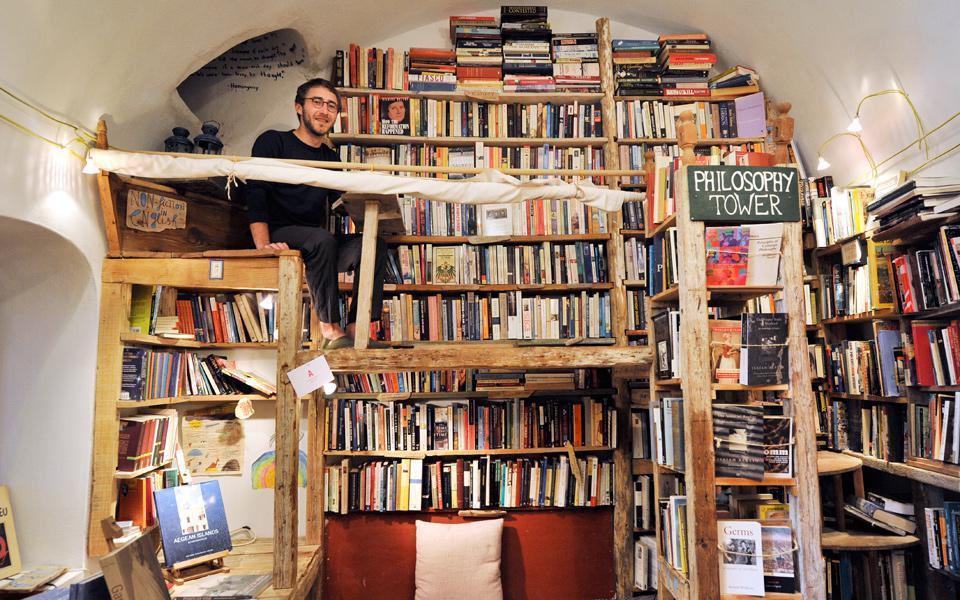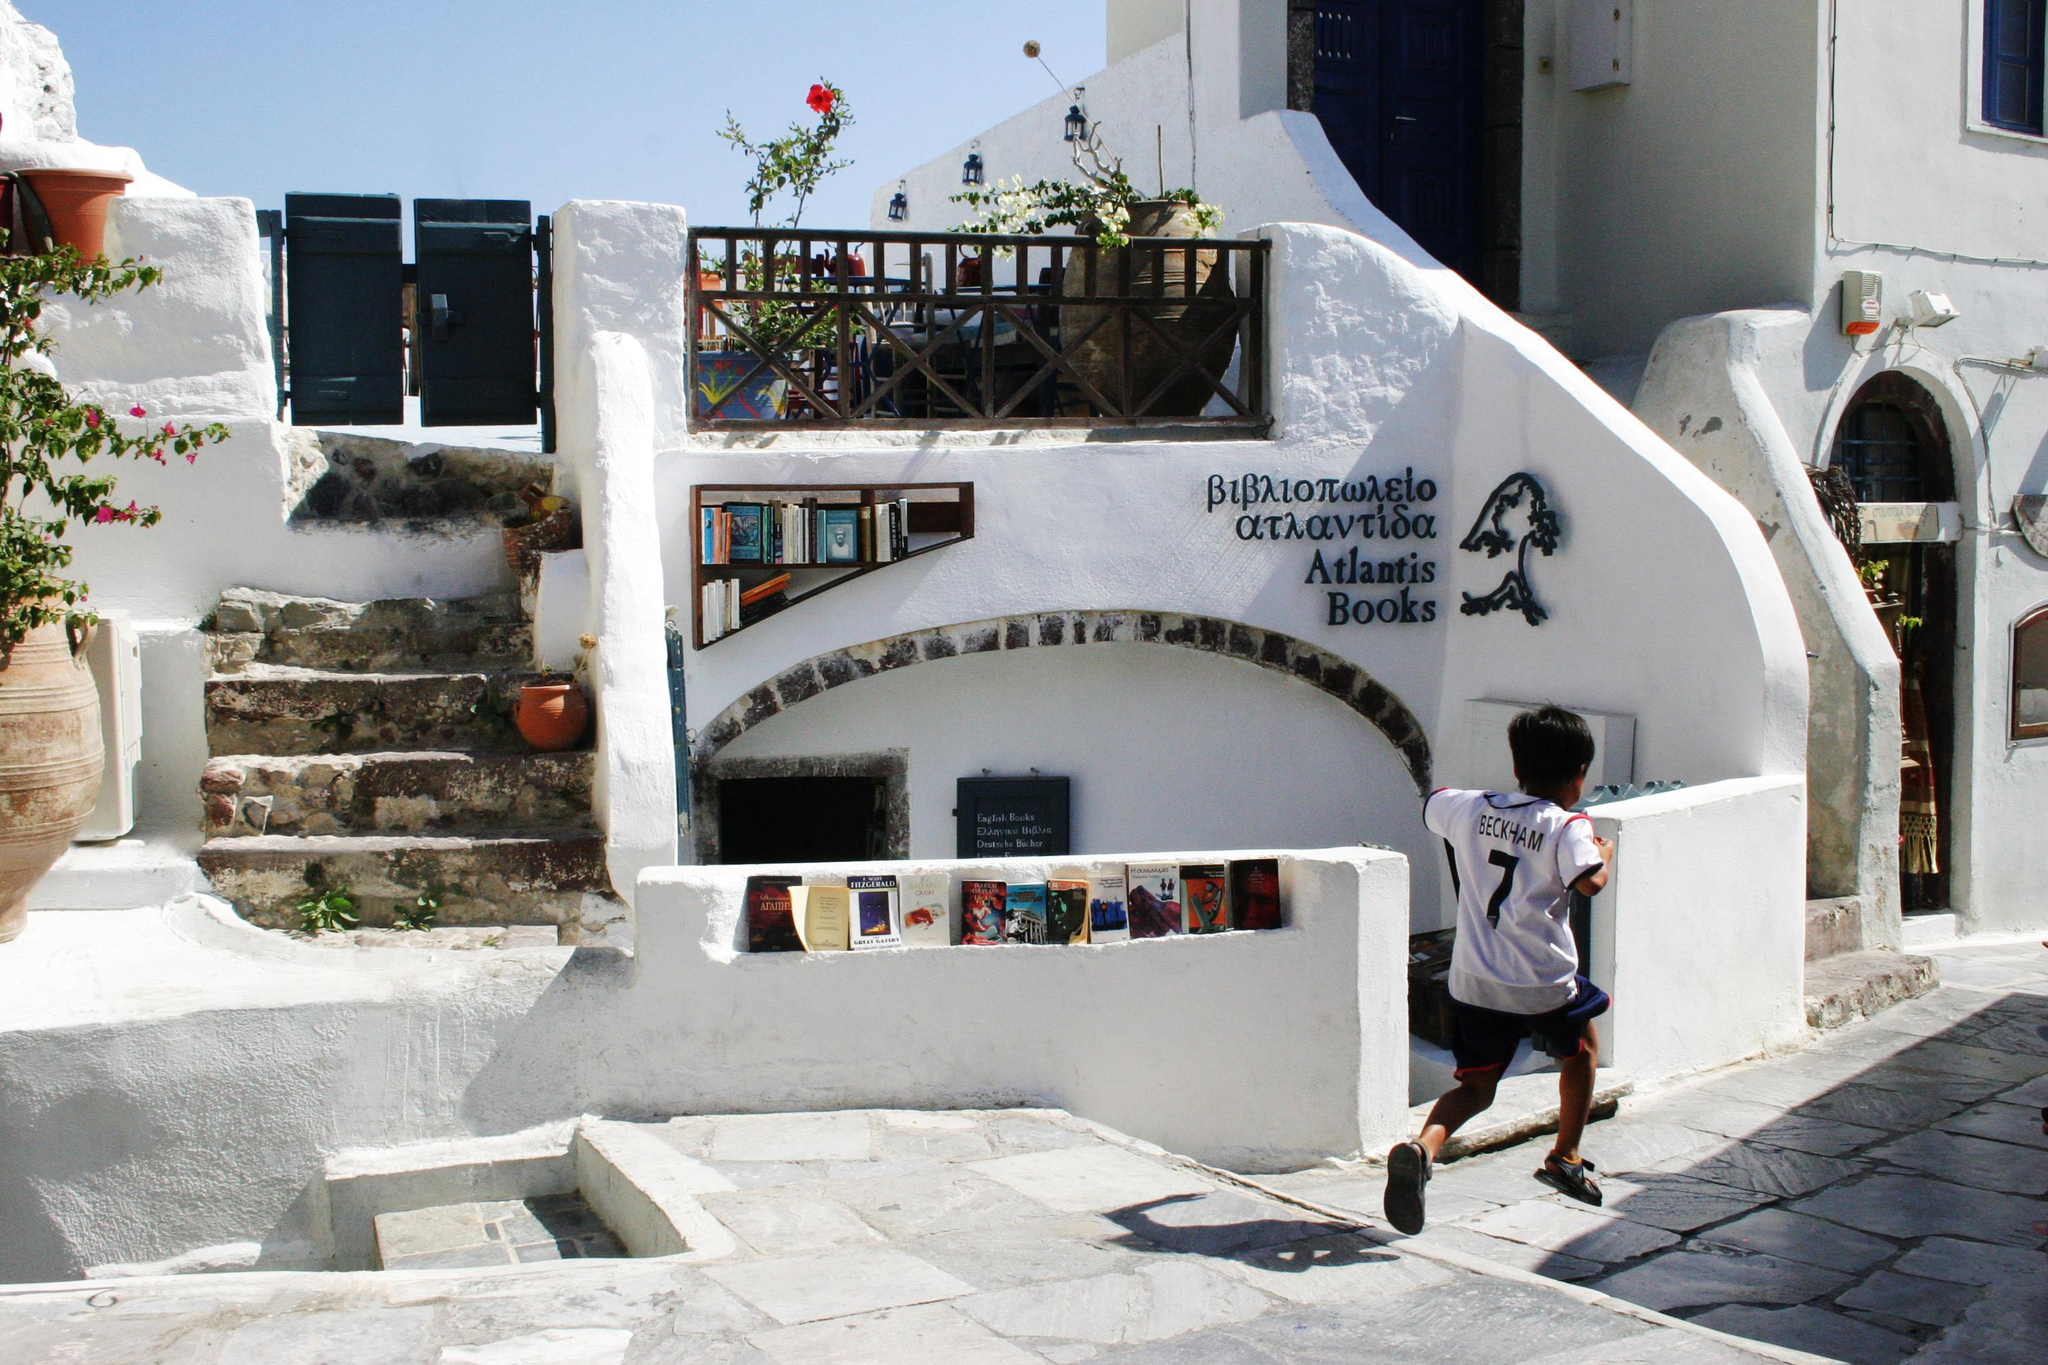The first image is the image on the left, the second image is the image on the right. Assess this claim about the two images: "An image of a room lined with shelves of books includes a stringed instrument near the center of the picture.". Correct or not? Answer yes or no. No. The first image is the image on the left, the second image is the image on the right. Considering the images on both sides, is "At least one person is near the bookstore in one of the images." valid? Answer yes or no. Yes. 